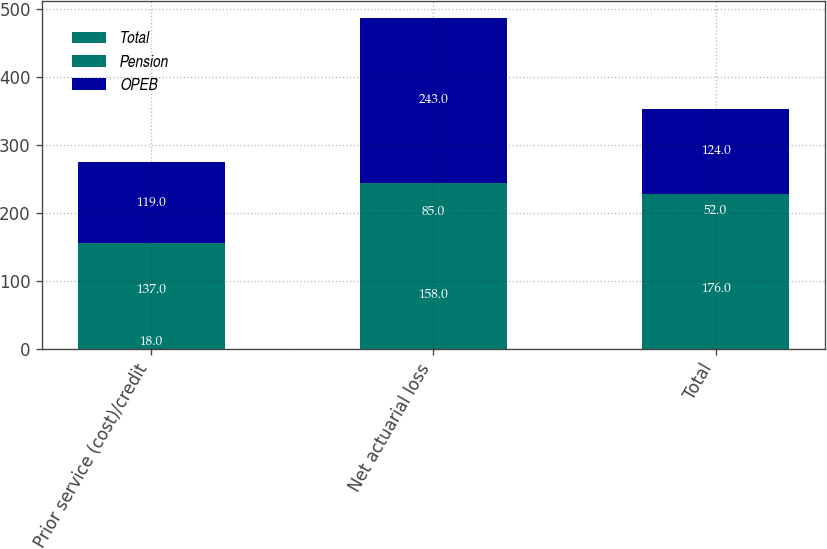Convert chart. <chart><loc_0><loc_0><loc_500><loc_500><stacked_bar_chart><ecel><fcel>Prior service (cost)/credit<fcel>Net actuarial loss<fcel>Total<nl><fcel>Total<fcel>18<fcel>158<fcel>176<nl><fcel>Pension<fcel>137<fcel>85<fcel>52<nl><fcel>OPEB<fcel>119<fcel>243<fcel>124<nl></chart> 